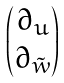<formula> <loc_0><loc_0><loc_500><loc_500>\begin{pmatrix} \partial _ { u } \\ \partial _ { \tilde { w } } \end{pmatrix}</formula> 